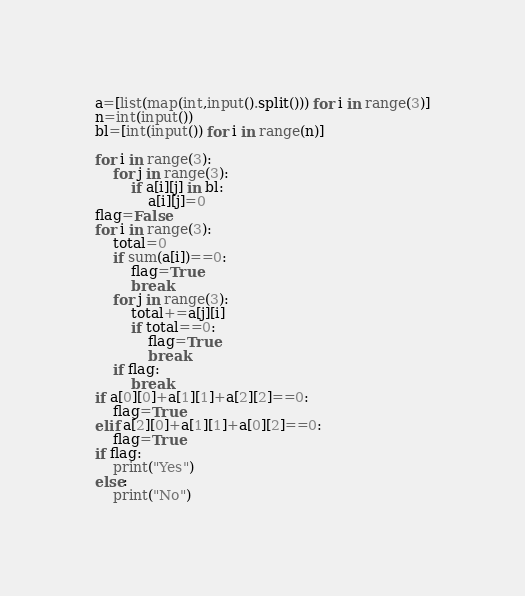<code> <loc_0><loc_0><loc_500><loc_500><_Python_>a=[list(map(int,input().split())) for i in range(3)]
n=int(input())
bl=[int(input()) for i in range(n)]

for i in range(3):
    for j in range(3):
        if a[i][j] in bl:
            a[i][j]=0
flag=False
for i in range(3):
    total=0
    if sum(a[i])==0:
        flag=True
        break
    for j in range(3):
        total+=a[j][i]
        if total==0:
            flag=True
            break
    if flag:
        break
if a[0][0]+a[1][1]+a[2][2]==0:
    flag=True
elif a[2][0]+a[1][1]+a[0][2]==0:
    flag=True
if flag:
    print("Yes")
else:
    print("No")</code> 